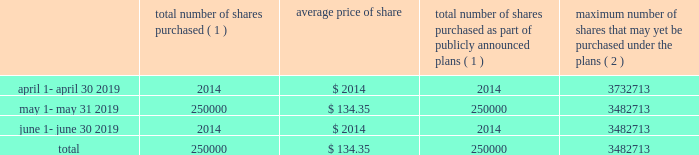J a c k h e n r y .
C o m 1 5 market for registrant 2019s common equity , related stockholder matters and issuer purchases of equity securities the company 2019s common stock is quoted on the nasdaq global select market ( 201cnasdaq 201d ) under the symbol 201cjkhy 201d .
The company established a practice of paying quarterly dividends at the end of fiscal 1990 and has paid dividends with respect to every quarter since that time .
The declaration and payment of any future dividends will continue to be at the discretion of our board of directors and will depend upon , among other factors , our earnings , capital requirements , contractual restrictions , and operating and financial condition .
The company does not currently foresee any changes in its dividend practices .
On august 15 , 2019 , there were approximately 145300 holders of the company 2019s common stock , including individual participants in security position listings .
On that same date the last sale price of the common shares as reported on nasdaq was $ 141.94 per share .
Issuer purchases of equity securities the following shares of the company were repurchased during the quarter ended june 30 , 2019 : total number of shares purchased ( 1 ) average price of total number of shares purchased as part of publicly announced plans ( 1 ) maximum number of shares that may yet be purchased under the plans ( 2 ) .
( 1 ) 250000 shares were purchased through a publicly announced repurchase plan .
There were no shares surrendered to the company to satisfy tax withholding obligations in connection with employee restricted stock awards .
( 2 ) total stock repurchase authorizations approved by the company 2019s board of directors as of february 17 , 2015 were for 30.0 million shares .
These authorizations have no specific dollar or share price targets and no expiration dates. .
What was the company market capitalization on august 15 , 2019,? 
Computations: (145300 * 141.94)
Answer: 20623882.0. 